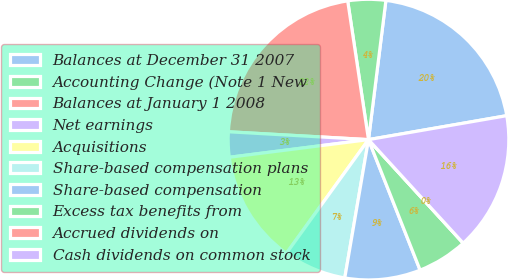<chart> <loc_0><loc_0><loc_500><loc_500><pie_chart><fcel>Balances at December 31 2007<fcel>Accounting Change (Note 1 New<fcel>Balances at January 1 2008<fcel>Net earnings<fcel>Acquisitions<fcel>Share-based compensation plans<fcel>Share-based compensation<fcel>Excess tax benefits from<fcel>Accrued dividends on<fcel>Cash dividends on common stock<nl><fcel>20.29%<fcel>4.35%<fcel>21.74%<fcel>2.9%<fcel>13.04%<fcel>7.25%<fcel>8.7%<fcel>5.8%<fcel>0.0%<fcel>15.94%<nl></chart> 